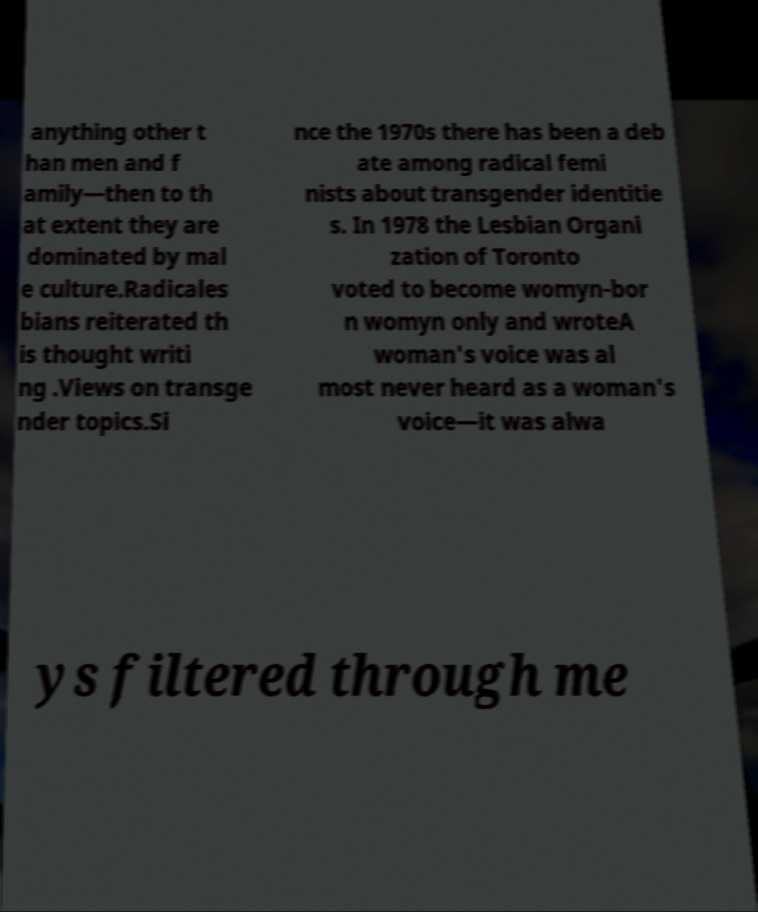Please read and relay the text visible in this image. What does it say? anything other t han men and f amily—then to th at extent they are dominated by mal e culture.Radicales bians reiterated th is thought writi ng .Views on transge nder topics.Si nce the 1970s there has been a deb ate among radical femi nists about transgender identitie s. In 1978 the Lesbian Organi zation of Toronto voted to become womyn-bor n womyn only and wroteA woman's voice was al most never heard as a woman's voice—it was alwa ys filtered through me 